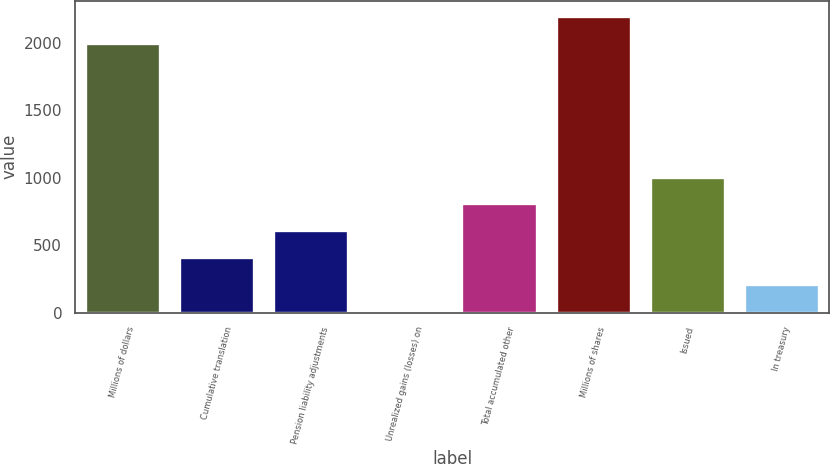<chart> <loc_0><loc_0><loc_500><loc_500><bar_chart><fcel>Millions of dollars<fcel>Cumulative translation<fcel>Pension liability adjustments<fcel>Unrealized gains (losses) on<fcel>Total accumulated other<fcel>Millions of shares<fcel>Issued<fcel>In treasury<nl><fcel>2004<fcel>412.8<fcel>611.7<fcel>15<fcel>810.6<fcel>2202.9<fcel>1009.5<fcel>213.9<nl></chart> 